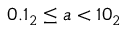<formula> <loc_0><loc_0><loc_500><loc_500>0 . 1 _ { 2 } \leq a < 1 0 _ { 2 }</formula> 